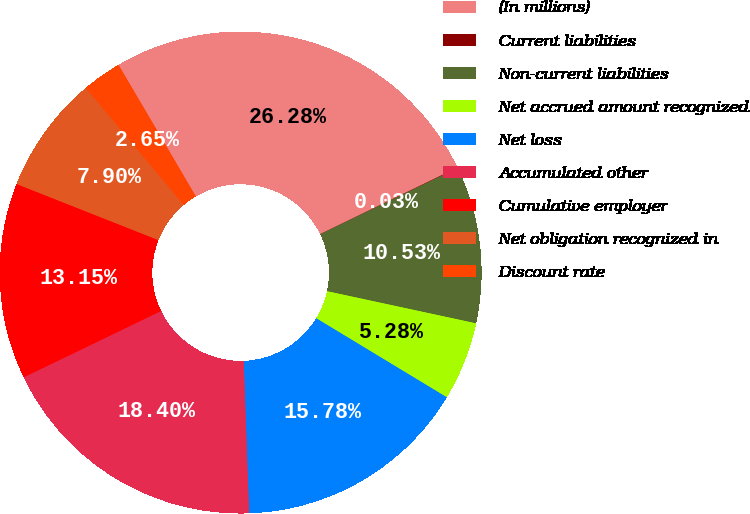Convert chart to OTSL. <chart><loc_0><loc_0><loc_500><loc_500><pie_chart><fcel>(In millions)<fcel>Current liabilities<fcel>Non-current liabilities<fcel>Net accrued amount recognized<fcel>Net loss<fcel>Accumulated other<fcel>Cumulative employer<fcel>Net obligation recognized in<fcel>Discount rate<nl><fcel>26.28%<fcel>0.03%<fcel>10.53%<fcel>5.28%<fcel>15.78%<fcel>18.4%<fcel>13.15%<fcel>7.9%<fcel>2.65%<nl></chart> 